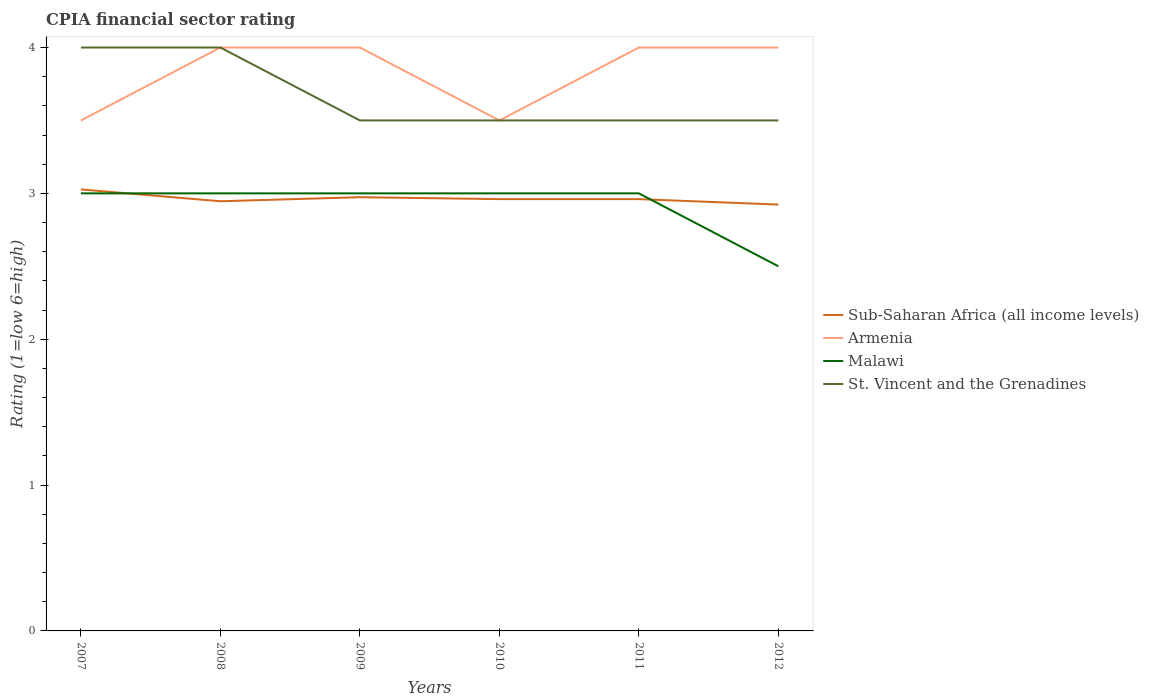How many different coloured lines are there?
Ensure brevity in your answer.  4. Is the number of lines equal to the number of legend labels?
Make the answer very short. Yes. In which year was the CPIA rating in Malawi maximum?
Your answer should be compact. 2012. What is the total CPIA rating in Sub-Saharan Africa (all income levels) in the graph?
Ensure brevity in your answer.  0.02. What is the difference between the highest and the lowest CPIA rating in Sub-Saharan Africa (all income levels)?
Provide a succinct answer. 2. Is the CPIA rating in Armenia strictly greater than the CPIA rating in Sub-Saharan Africa (all income levels) over the years?
Keep it short and to the point. No. How many lines are there?
Keep it short and to the point. 4. What is the difference between two consecutive major ticks on the Y-axis?
Offer a very short reply. 1. How many legend labels are there?
Offer a terse response. 4. How are the legend labels stacked?
Make the answer very short. Vertical. What is the title of the graph?
Keep it short and to the point. CPIA financial sector rating. Does "Norway" appear as one of the legend labels in the graph?
Your response must be concise. No. What is the label or title of the X-axis?
Provide a succinct answer. Years. What is the Rating (1=low 6=high) of Sub-Saharan Africa (all income levels) in 2007?
Provide a succinct answer. 3.03. What is the Rating (1=low 6=high) of Armenia in 2007?
Provide a short and direct response. 3.5. What is the Rating (1=low 6=high) of Sub-Saharan Africa (all income levels) in 2008?
Your response must be concise. 2.95. What is the Rating (1=low 6=high) of St. Vincent and the Grenadines in 2008?
Give a very brief answer. 4. What is the Rating (1=low 6=high) of Sub-Saharan Africa (all income levels) in 2009?
Provide a succinct answer. 2.97. What is the Rating (1=low 6=high) in Malawi in 2009?
Offer a terse response. 3. What is the Rating (1=low 6=high) of St. Vincent and the Grenadines in 2009?
Keep it short and to the point. 3.5. What is the Rating (1=low 6=high) of Sub-Saharan Africa (all income levels) in 2010?
Offer a very short reply. 2.96. What is the Rating (1=low 6=high) in Armenia in 2010?
Make the answer very short. 3.5. What is the Rating (1=low 6=high) in Sub-Saharan Africa (all income levels) in 2011?
Offer a very short reply. 2.96. What is the Rating (1=low 6=high) in Malawi in 2011?
Your response must be concise. 3. What is the Rating (1=low 6=high) in St. Vincent and the Grenadines in 2011?
Keep it short and to the point. 3.5. What is the Rating (1=low 6=high) in Sub-Saharan Africa (all income levels) in 2012?
Your answer should be compact. 2.92. What is the Rating (1=low 6=high) in Malawi in 2012?
Keep it short and to the point. 2.5. What is the Rating (1=low 6=high) in St. Vincent and the Grenadines in 2012?
Make the answer very short. 3.5. Across all years, what is the maximum Rating (1=low 6=high) in Sub-Saharan Africa (all income levels)?
Your answer should be very brief. 3.03. Across all years, what is the maximum Rating (1=low 6=high) of Armenia?
Provide a succinct answer. 4. Across all years, what is the maximum Rating (1=low 6=high) in Malawi?
Offer a terse response. 3. Across all years, what is the minimum Rating (1=low 6=high) in Sub-Saharan Africa (all income levels)?
Give a very brief answer. 2.92. Across all years, what is the minimum Rating (1=low 6=high) in Malawi?
Make the answer very short. 2.5. What is the total Rating (1=low 6=high) of Sub-Saharan Africa (all income levels) in the graph?
Your answer should be compact. 17.79. What is the total Rating (1=low 6=high) in Armenia in the graph?
Provide a succinct answer. 23. What is the total Rating (1=low 6=high) of Malawi in the graph?
Your response must be concise. 17.5. What is the total Rating (1=low 6=high) of St. Vincent and the Grenadines in the graph?
Offer a terse response. 22. What is the difference between the Rating (1=low 6=high) of Sub-Saharan Africa (all income levels) in 2007 and that in 2008?
Provide a succinct answer. 0.08. What is the difference between the Rating (1=low 6=high) of Armenia in 2007 and that in 2008?
Make the answer very short. -0.5. What is the difference between the Rating (1=low 6=high) in St. Vincent and the Grenadines in 2007 and that in 2008?
Offer a very short reply. 0. What is the difference between the Rating (1=low 6=high) in Sub-Saharan Africa (all income levels) in 2007 and that in 2009?
Offer a terse response. 0.05. What is the difference between the Rating (1=low 6=high) in Malawi in 2007 and that in 2009?
Give a very brief answer. 0. What is the difference between the Rating (1=low 6=high) of St. Vincent and the Grenadines in 2007 and that in 2009?
Ensure brevity in your answer.  0.5. What is the difference between the Rating (1=low 6=high) of Sub-Saharan Africa (all income levels) in 2007 and that in 2010?
Give a very brief answer. 0.07. What is the difference between the Rating (1=low 6=high) of Armenia in 2007 and that in 2010?
Your answer should be very brief. 0. What is the difference between the Rating (1=low 6=high) in Sub-Saharan Africa (all income levels) in 2007 and that in 2011?
Offer a very short reply. 0.07. What is the difference between the Rating (1=low 6=high) of Malawi in 2007 and that in 2011?
Give a very brief answer. 0. What is the difference between the Rating (1=low 6=high) of Sub-Saharan Africa (all income levels) in 2007 and that in 2012?
Provide a succinct answer. 0.1. What is the difference between the Rating (1=low 6=high) of Armenia in 2007 and that in 2012?
Your answer should be compact. -0.5. What is the difference between the Rating (1=low 6=high) of Malawi in 2007 and that in 2012?
Provide a short and direct response. 0.5. What is the difference between the Rating (1=low 6=high) in St. Vincent and the Grenadines in 2007 and that in 2012?
Your response must be concise. 0.5. What is the difference between the Rating (1=low 6=high) in Sub-Saharan Africa (all income levels) in 2008 and that in 2009?
Provide a succinct answer. -0.03. What is the difference between the Rating (1=low 6=high) of Armenia in 2008 and that in 2009?
Ensure brevity in your answer.  0. What is the difference between the Rating (1=low 6=high) in St. Vincent and the Grenadines in 2008 and that in 2009?
Ensure brevity in your answer.  0.5. What is the difference between the Rating (1=low 6=high) of Sub-Saharan Africa (all income levels) in 2008 and that in 2010?
Your response must be concise. -0.01. What is the difference between the Rating (1=low 6=high) in Armenia in 2008 and that in 2010?
Provide a short and direct response. 0.5. What is the difference between the Rating (1=low 6=high) in Malawi in 2008 and that in 2010?
Your response must be concise. 0. What is the difference between the Rating (1=low 6=high) of Sub-Saharan Africa (all income levels) in 2008 and that in 2011?
Make the answer very short. -0.01. What is the difference between the Rating (1=low 6=high) in St. Vincent and the Grenadines in 2008 and that in 2011?
Provide a succinct answer. 0.5. What is the difference between the Rating (1=low 6=high) of Sub-Saharan Africa (all income levels) in 2008 and that in 2012?
Provide a short and direct response. 0.02. What is the difference between the Rating (1=low 6=high) of Armenia in 2008 and that in 2012?
Keep it short and to the point. 0. What is the difference between the Rating (1=low 6=high) of Sub-Saharan Africa (all income levels) in 2009 and that in 2010?
Offer a very short reply. 0.01. What is the difference between the Rating (1=low 6=high) of St. Vincent and the Grenadines in 2009 and that in 2010?
Provide a succinct answer. 0. What is the difference between the Rating (1=low 6=high) of Sub-Saharan Africa (all income levels) in 2009 and that in 2011?
Provide a succinct answer. 0.01. What is the difference between the Rating (1=low 6=high) of Malawi in 2009 and that in 2011?
Provide a succinct answer. 0. What is the difference between the Rating (1=low 6=high) in St. Vincent and the Grenadines in 2009 and that in 2011?
Offer a very short reply. 0. What is the difference between the Rating (1=low 6=high) of Sub-Saharan Africa (all income levels) in 2009 and that in 2012?
Your answer should be compact. 0.05. What is the difference between the Rating (1=low 6=high) in Sub-Saharan Africa (all income levels) in 2010 and that in 2012?
Provide a short and direct response. 0.04. What is the difference between the Rating (1=low 6=high) of St. Vincent and the Grenadines in 2010 and that in 2012?
Ensure brevity in your answer.  0. What is the difference between the Rating (1=low 6=high) in Sub-Saharan Africa (all income levels) in 2011 and that in 2012?
Your answer should be very brief. 0.04. What is the difference between the Rating (1=low 6=high) in Malawi in 2011 and that in 2012?
Make the answer very short. 0.5. What is the difference between the Rating (1=low 6=high) in Sub-Saharan Africa (all income levels) in 2007 and the Rating (1=low 6=high) in Armenia in 2008?
Give a very brief answer. -0.97. What is the difference between the Rating (1=low 6=high) in Sub-Saharan Africa (all income levels) in 2007 and the Rating (1=low 6=high) in Malawi in 2008?
Make the answer very short. 0.03. What is the difference between the Rating (1=low 6=high) of Sub-Saharan Africa (all income levels) in 2007 and the Rating (1=low 6=high) of St. Vincent and the Grenadines in 2008?
Make the answer very short. -0.97. What is the difference between the Rating (1=low 6=high) in Sub-Saharan Africa (all income levels) in 2007 and the Rating (1=low 6=high) in Armenia in 2009?
Make the answer very short. -0.97. What is the difference between the Rating (1=low 6=high) in Sub-Saharan Africa (all income levels) in 2007 and the Rating (1=low 6=high) in Malawi in 2009?
Your answer should be very brief. 0.03. What is the difference between the Rating (1=low 6=high) of Sub-Saharan Africa (all income levels) in 2007 and the Rating (1=low 6=high) of St. Vincent and the Grenadines in 2009?
Offer a terse response. -0.47. What is the difference between the Rating (1=low 6=high) in Armenia in 2007 and the Rating (1=low 6=high) in Malawi in 2009?
Offer a terse response. 0.5. What is the difference between the Rating (1=low 6=high) in Armenia in 2007 and the Rating (1=low 6=high) in St. Vincent and the Grenadines in 2009?
Offer a terse response. 0. What is the difference between the Rating (1=low 6=high) in Sub-Saharan Africa (all income levels) in 2007 and the Rating (1=low 6=high) in Armenia in 2010?
Offer a very short reply. -0.47. What is the difference between the Rating (1=low 6=high) of Sub-Saharan Africa (all income levels) in 2007 and the Rating (1=low 6=high) of Malawi in 2010?
Your answer should be very brief. 0.03. What is the difference between the Rating (1=low 6=high) of Sub-Saharan Africa (all income levels) in 2007 and the Rating (1=low 6=high) of St. Vincent and the Grenadines in 2010?
Your answer should be compact. -0.47. What is the difference between the Rating (1=low 6=high) in Sub-Saharan Africa (all income levels) in 2007 and the Rating (1=low 6=high) in Armenia in 2011?
Make the answer very short. -0.97. What is the difference between the Rating (1=low 6=high) in Sub-Saharan Africa (all income levels) in 2007 and the Rating (1=low 6=high) in Malawi in 2011?
Keep it short and to the point. 0.03. What is the difference between the Rating (1=low 6=high) in Sub-Saharan Africa (all income levels) in 2007 and the Rating (1=low 6=high) in St. Vincent and the Grenadines in 2011?
Give a very brief answer. -0.47. What is the difference between the Rating (1=low 6=high) in Armenia in 2007 and the Rating (1=low 6=high) in St. Vincent and the Grenadines in 2011?
Provide a succinct answer. 0. What is the difference between the Rating (1=low 6=high) in Malawi in 2007 and the Rating (1=low 6=high) in St. Vincent and the Grenadines in 2011?
Your answer should be very brief. -0.5. What is the difference between the Rating (1=low 6=high) in Sub-Saharan Africa (all income levels) in 2007 and the Rating (1=low 6=high) in Armenia in 2012?
Keep it short and to the point. -0.97. What is the difference between the Rating (1=low 6=high) of Sub-Saharan Africa (all income levels) in 2007 and the Rating (1=low 6=high) of Malawi in 2012?
Provide a short and direct response. 0.53. What is the difference between the Rating (1=low 6=high) of Sub-Saharan Africa (all income levels) in 2007 and the Rating (1=low 6=high) of St. Vincent and the Grenadines in 2012?
Offer a terse response. -0.47. What is the difference between the Rating (1=low 6=high) in Armenia in 2007 and the Rating (1=low 6=high) in Malawi in 2012?
Offer a terse response. 1. What is the difference between the Rating (1=low 6=high) of Malawi in 2007 and the Rating (1=low 6=high) of St. Vincent and the Grenadines in 2012?
Provide a succinct answer. -0.5. What is the difference between the Rating (1=low 6=high) in Sub-Saharan Africa (all income levels) in 2008 and the Rating (1=low 6=high) in Armenia in 2009?
Offer a very short reply. -1.05. What is the difference between the Rating (1=low 6=high) in Sub-Saharan Africa (all income levels) in 2008 and the Rating (1=low 6=high) in Malawi in 2009?
Keep it short and to the point. -0.05. What is the difference between the Rating (1=low 6=high) in Sub-Saharan Africa (all income levels) in 2008 and the Rating (1=low 6=high) in St. Vincent and the Grenadines in 2009?
Provide a succinct answer. -0.55. What is the difference between the Rating (1=low 6=high) of Armenia in 2008 and the Rating (1=low 6=high) of St. Vincent and the Grenadines in 2009?
Offer a very short reply. 0.5. What is the difference between the Rating (1=low 6=high) of Malawi in 2008 and the Rating (1=low 6=high) of St. Vincent and the Grenadines in 2009?
Your answer should be compact. -0.5. What is the difference between the Rating (1=low 6=high) in Sub-Saharan Africa (all income levels) in 2008 and the Rating (1=low 6=high) in Armenia in 2010?
Your answer should be compact. -0.55. What is the difference between the Rating (1=low 6=high) in Sub-Saharan Africa (all income levels) in 2008 and the Rating (1=low 6=high) in Malawi in 2010?
Your answer should be very brief. -0.05. What is the difference between the Rating (1=low 6=high) of Sub-Saharan Africa (all income levels) in 2008 and the Rating (1=low 6=high) of St. Vincent and the Grenadines in 2010?
Offer a terse response. -0.55. What is the difference between the Rating (1=low 6=high) of Armenia in 2008 and the Rating (1=low 6=high) of St. Vincent and the Grenadines in 2010?
Make the answer very short. 0.5. What is the difference between the Rating (1=low 6=high) in Malawi in 2008 and the Rating (1=low 6=high) in St. Vincent and the Grenadines in 2010?
Your answer should be very brief. -0.5. What is the difference between the Rating (1=low 6=high) of Sub-Saharan Africa (all income levels) in 2008 and the Rating (1=low 6=high) of Armenia in 2011?
Ensure brevity in your answer.  -1.05. What is the difference between the Rating (1=low 6=high) of Sub-Saharan Africa (all income levels) in 2008 and the Rating (1=low 6=high) of Malawi in 2011?
Keep it short and to the point. -0.05. What is the difference between the Rating (1=low 6=high) in Sub-Saharan Africa (all income levels) in 2008 and the Rating (1=low 6=high) in St. Vincent and the Grenadines in 2011?
Provide a short and direct response. -0.55. What is the difference between the Rating (1=low 6=high) of Armenia in 2008 and the Rating (1=low 6=high) of Malawi in 2011?
Offer a very short reply. 1. What is the difference between the Rating (1=low 6=high) in Sub-Saharan Africa (all income levels) in 2008 and the Rating (1=low 6=high) in Armenia in 2012?
Give a very brief answer. -1.05. What is the difference between the Rating (1=low 6=high) of Sub-Saharan Africa (all income levels) in 2008 and the Rating (1=low 6=high) of Malawi in 2012?
Ensure brevity in your answer.  0.45. What is the difference between the Rating (1=low 6=high) in Sub-Saharan Africa (all income levels) in 2008 and the Rating (1=low 6=high) in St. Vincent and the Grenadines in 2012?
Your answer should be very brief. -0.55. What is the difference between the Rating (1=low 6=high) in Armenia in 2008 and the Rating (1=low 6=high) in Malawi in 2012?
Offer a very short reply. 1.5. What is the difference between the Rating (1=low 6=high) in Sub-Saharan Africa (all income levels) in 2009 and the Rating (1=low 6=high) in Armenia in 2010?
Provide a succinct answer. -0.53. What is the difference between the Rating (1=low 6=high) of Sub-Saharan Africa (all income levels) in 2009 and the Rating (1=low 6=high) of Malawi in 2010?
Provide a succinct answer. -0.03. What is the difference between the Rating (1=low 6=high) of Sub-Saharan Africa (all income levels) in 2009 and the Rating (1=low 6=high) of St. Vincent and the Grenadines in 2010?
Your answer should be very brief. -0.53. What is the difference between the Rating (1=low 6=high) in Armenia in 2009 and the Rating (1=low 6=high) in Malawi in 2010?
Provide a succinct answer. 1. What is the difference between the Rating (1=low 6=high) in Sub-Saharan Africa (all income levels) in 2009 and the Rating (1=low 6=high) in Armenia in 2011?
Your answer should be very brief. -1.03. What is the difference between the Rating (1=low 6=high) of Sub-Saharan Africa (all income levels) in 2009 and the Rating (1=low 6=high) of Malawi in 2011?
Give a very brief answer. -0.03. What is the difference between the Rating (1=low 6=high) of Sub-Saharan Africa (all income levels) in 2009 and the Rating (1=low 6=high) of St. Vincent and the Grenadines in 2011?
Keep it short and to the point. -0.53. What is the difference between the Rating (1=low 6=high) in Armenia in 2009 and the Rating (1=low 6=high) in St. Vincent and the Grenadines in 2011?
Your answer should be very brief. 0.5. What is the difference between the Rating (1=low 6=high) in Malawi in 2009 and the Rating (1=low 6=high) in St. Vincent and the Grenadines in 2011?
Your answer should be very brief. -0.5. What is the difference between the Rating (1=low 6=high) of Sub-Saharan Africa (all income levels) in 2009 and the Rating (1=low 6=high) of Armenia in 2012?
Give a very brief answer. -1.03. What is the difference between the Rating (1=low 6=high) of Sub-Saharan Africa (all income levels) in 2009 and the Rating (1=low 6=high) of Malawi in 2012?
Your answer should be very brief. 0.47. What is the difference between the Rating (1=low 6=high) of Sub-Saharan Africa (all income levels) in 2009 and the Rating (1=low 6=high) of St. Vincent and the Grenadines in 2012?
Your answer should be very brief. -0.53. What is the difference between the Rating (1=low 6=high) in Armenia in 2009 and the Rating (1=low 6=high) in Malawi in 2012?
Give a very brief answer. 1.5. What is the difference between the Rating (1=low 6=high) in Armenia in 2009 and the Rating (1=low 6=high) in St. Vincent and the Grenadines in 2012?
Your answer should be compact. 0.5. What is the difference between the Rating (1=low 6=high) in Malawi in 2009 and the Rating (1=low 6=high) in St. Vincent and the Grenadines in 2012?
Offer a very short reply. -0.5. What is the difference between the Rating (1=low 6=high) in Sub-Saharan Africa (all income levels) in 2010 and the Rating (1=low 6=high) in Armenia in 2011?
Ensure brevity in your answer.  -1.04. What is the difference between the Rating (1=low 6=high) in Sub-Saharan Africa (all income levels) in 2010 and the Rating (1=low 6=high) in Malawi in 2011?
Your response must be concise. -0.04. What is the difference between the Rating (1=low 6=high) in Sub-Saharan Africa (all income levels) in 2010 and the Rating (1=low 6=high) in St. Vincent and the Grenadines in 2011?
Provide a succinct answer. -0.54. What is the difference between the Rating (1=low 6=high) in Armenia in 2010 and the Rating (1=low 6=high) in Malawi in 2011?
Your answer should be very brief. 0.5. What is the difference between the Rating (1=low 6=high) of Malawi in 2010 and the Rating (1=low 6=high) of St. Vincent and the Grenadines in 2011?
Offer a very short reply. -0.5. What is the difference between the Rating (1=low 6=high) in Sub-Saharan Africa (all income levels) in 2010 and the Rating (1=low 6=high) in Armenia in 2012?
Give a very brief answer. -1.04. What is the difference between the Rating (1=low 6=high) of Sub-Saharan Africa (all income levels) in 2010 and the Rating (1=low 6=high) of Malawi in 2012?
Offer a terse response. 0.46. What is the difference between the Rating (1=low 6=high) of Sub-Saharan Africa (all income levels) in 2010 and the Rating (1=low 6=high) of St. Vincent and the Grenadines in 2012?
Make the answer very short. -0.54. What is the difference between the Rating (1=low 6=high) of Armenia in 2010 and the Rating (1=low 6=high) of St. Vincent and the Grenadines in 2012?
Your answer should be very brief. 0. What is the difference between the Rating (1=low 6=high) in Malawi in 2010 and the Rating (1=low 6=high) in St. Vincent and the Grenadines in 2012?
Provide a succinct answer. -0.5. What is the difference between the Rating (1=low 6=high) of Sub-Saharan Africa (all income levels) in 2011 and the Rating (1=low 6=high) of Armenia in 2012?
Ensure brevity in your answer.  -1.04. What is the difference between the Rating (1=low 6=high) in Sub-Saharan Africa (all income levels) in 2011 and the Rating (1=low 6=high) in Malawi in 2012?
Provide a short and direct response. 0.46. What is the difference between the Rating (1=low 6=high) in Sub-Saharan Africa (all income levels) in 2011 and the Rating (1=low 6=high) in St. Vincent and the Grenadines in 2012?
Provide a short and direct response. -0.54. What is the average Rating (1=low 6=high) in Sub-Saharan Africa (all income levels) per year?
Keep it short and to the point. 2.97. What is the average Rating (1=low 6=high) of Armenia per year?
Your answer should be compact. 3.83. What is the average Rating (1=low 6=high) of Malawi per year?
Keep it short and to the point. 2.92. What is the average Rating (1=low 6=high) of St. Vincent and the Grenadines per year?
Your response must be concise. 3.67. In the year 2007, what is the difference between the Rating (1=low 6=high) in Sub-Saharan Africa (all income levels) and Rating (1=low 6=high) in Armenia?
Offer a terse response. -0.47. In the year 2007, what is the difference between the Rating (1=low 6=high) in Sub-Saharan Africa (all income levels) and Rating (1=low 6=high) in Malawi?
Provide a succinct answer. 0.03. In the year 2007, what is the difference between the Rating (1=low 6=high) of Sub-Saharan Africa (all income levels) and Rating (1=low 6=high) of St. Vincent and the Grenadines?
Give a very brief answer. -0.97. In the year 2007, what is the difference between the Rating (1=low 6=high) in Armenia and Rating (1=low 6=high) in Malawi?
Your answer should be compact. 0.5. In the year 2007, what is the difference between the Rating (1=low 6=high) of Armenia and Rating (1=low 6=high) of St. Vincent and the Grenadines?
Provide a succinct answer. -0.5. In the year 2007, what is the difference between the Rating (1=low 6=high) in Malawi and Rating (1=low 6=high) in St. Vincent and the Grenadines?
Provide a succinct answer. -1. In the year 2008, what is the difference between the Rating (1=low 6=high) of Sub-Saharan Africa (all income levels) and Rating (1=low 6=high) of Armenia?
Your answer should be compact. -1.05. In the year 2008, what is the difference between the Rating (1=low 6=high) in Sub-Saharan Africa (all income levels) and Rating (1=low 6=high) in Malawi?
Offer a very short reply. -0.05. In the year 2008, what is the difference between the Rating (1=low 6=high) of Sub-Saharan Africa (all income levels) and Rating (1=low 6=high) of St. Vincent and the Grenadines?
Offer a terse response. -1.05. In the year 2008, what is the difference between the Rating (1=low 6=high) of Armenia and Rating (1=low 6=high) of Malawi?
Offer a terse response. 1. In the year 2008, what is the difference between the Rating (1=low 6=high) of Armenia and Rating (1=low 6=high) of St. Vincent and the Grenadines?
Offer a terse response. 0. In the year 2008, what is the difference between the Rating (1=low 6=high) of Malawi and Rating (1=low 6=high) of St. Vincent and the Grenadines?
Give a very brief answer. -1. In the year 2009, what is the difference between the Rating (1=low 6=high) in Sub-Saharan Africa (all income levels) and Rating (1=low 6=high) in Armenia?
Make the answer very short. -1.03. In the year 2009, what is the difference between the Rating (1=low 6=high) in Sub-Saharan Africa (all income levels) and Rating (1=low 6=high) in Malawi?
Make the answer very short. -0.03. In the year 2009, what is the difference between the Rating (1=low 6=high) of Sub-Saharan Africa (all income levels) and Rating (1=low 6=high) of St. Vincent and the Grenadines?
Keep it short and to the point. -0.53. In the year 2010, what is the difference between the Rating (1=low 6=high) of Sub-Saharan Africa (all income levels) and Rating (1=low 6=high) of Armenia?
Your answer should be compact. -0.54. In the year 2010, what is the difference between the Rating (1=low 6=high) in Sub-Saharan Africa (all income levels) and Rating (1=low 6=high) in Malawi?
Your answer should be compact. -0.04. In the year 2010, what is the difference between the Rating (1=low 6=high) of Sub-Saharan Africa (all income levels) and Rating (1=low 6=high) of St. Vincent and the Grenadines?
Keep it short and to the point. -0.54. In the year 2010, what is the difference between the Rating (1=low 6=high) in Armenia and Rating (1=low 6=high) in St. Vincent and the Grenadines?
Offer a terse response. 0. In the year 2010, what is the difference between the Rating (1=low 6=high) in Malawi and Rating (1=low 6=high) in St. Vincent and the Grenadines?
Provide a succinct answer. -0.5. In the year 2011, what is the difference between the Rating (1=low 6=high) in Sub-Saharan Africa (all income levels) and Rating (1=low 6=high) in Armenia?
Your answer should be compact. -1.04. In the year 2011, what is the difference between the Rating (1=low 6=high) in Sub-Saharan Africa (all income levels) and Rating (1=low 6=high) in Malawi?
Give a very brief answer. -0.04. In the year 2011, what is the difference between the Rating (1=low 6=high) of Sub-Saharan Africa (all income levels) and Rating (1=low 6=high) of St. Vincent and the Grenadines?
Your answer should be compact. -0.54. In the year 2011, what is the difference between the Rating (1=low 6=high) in Armenia and Rating (1=low 6=high) in Malawi?
Provide a short and direct response. 1. In the year 2011, what is the difference between the Rating (1=low 6=high) of Armenia and Rating (1=low 6=high) of St. Vincent and the Grenadines?
Your answer should be compact. 0.5. In the year 2012, what is the difference between the Rating (1=low 6=high) of Sub-Saharan Africa (all income levels) and Rating (1=low 6=high) of Armenia?
Your response must be concise. -1.08. In the year 2012, what is the difference between the Rating (1=low 6=high) of Sub-Saharan Africa (all income levels) and Rating (1=low 6=high) of Malawi?
Provide a succinct answer. 0.42. In the year 2012, what is the difference between the Rating (1=low 6=high) in Sub-Saharan Africa (all income levels) and Rating (1=low 6=high) in St. Vincent and the Grenadines?
Offer a terse response. -0.58. In the year 2012, what is the difference between the Rating (1=low 6=high) of Armenia and Rating (1=low 6=high) of Malawi?
Offer a very short reply. 1.5. In the year 2012, what is the difference between the Rating (1=low 6=high) in Armenia and Rating (1=low 6=high) in St. Vincent and the Grenadines?
Your answer should be compact. 0.5. What is the ratio of the Rating (1=low 6=high) of Sub-Saharan Africa (all income levels) in 2007 to that in 2008?
Provide a short and direct response. 1.03. What is the ratio of the Rating (1=low 6=high) in St. Vincent and the Grenadines in 2007 to that in 2008?
Provide a short and direct response. 1. What is the ratio of the Rating (1=low 6=high) of Sub-Saharan Africa (all income levels) in 2007 to that in 2009?
Your answer should be very brief. 1.02. What is the ratio of the Rating (1=low 6=high) in Malawi in 2007 to that in 2009?
Provide a short and direct response. 1. What is the ratio of the Rating (1=low 6=high) of St. Vincent and the Grenadines in 2007 to that in 2009?
Offer a terse response. 1.14. What is the ratio of the Rating (1=low 6=high) of Sub-Saharan Africa (all income levels) in 2007 to that in 2010?
Give a very brief answer. 1.02. What is the ratio of the Rating (1=low 6=high) in St. Vincent and the Grenadines in 2007 to that in 2010?
Make the answer very short. 1.14. What is the ratio of the Rating (1=low 6=high) of Sub-Saharan Africa (all income levels) in 2007 to that in 2011?
Your answer should be very brief. 1.02. What is the ratio of the Rating (1=low 6=high) of St. Vincent and the Grenadines in 2007 to that in 2011?
Provide a short and direct response. 1.14. What is the ratio of the Rating (1=low 6=high) in Sub-Saharan Africa (all income levels) in 2007 to that in 2012?
Ensure brevity in your answer.  1.04. What is the ratio of the Rating (1=low 6=high) in Armenia in 2007 to that in 2012?
Provide a succinct answer. 0.88. What is the ratio of the Rating (1=low 6=high) in Malawi in 2007 to that in 2012?
Your response must be concise. 1.2. What is the ratio of the Rating (1=low 6=high) in Sub-Saharan Africa (all income levels) in 2008 to that in 2009?
Keep it short and to the point. 0.99. What is the ratio of the Rating (1=low 6=high) of Malawi in 2008 to that in 2009?
Make the answer very short. 1. What is the ratio of the Rating (1=low 6=high) of St. Vincent and the Grenadines in 2008 to that in 2009?
Your response must be concise. 1.14. What is the ratio of the Rating (1=low 6=high) in Sub-Saharan Africa (all income levels) in 2008 to that in 2010?
Ensure brevity in your answer.  1. What is the ratio of the Rating (1=low 6=high) in Malawi in 2008 to that in 2010?
Your answer should be compact. 1. What is the ratio of the Rating (1=low 6=high) of St. Vincent and the Grenadines in 2008 to that in 2010?
Keep it short and to the point. 1.14. What is the ratio of the Rating (1=low 6=high) in Sub-Saharan Africa (all income levels) in 2008 to that in 2011?
Provide a succinct answer. 1. What is the ratio of the Rating (1=low 6=high) in Malawi in 2008 to that in 2011?
Provide a succinct answer. 1. What is the ratio of the Rating (1=low 6=high) in Sub-Saharan Africa (all income levels) in 2008 to that in 2012?
Provide a succinct answer. 1.01. What is the ratio of the Rating (1=low 6=high) in Malawi in 2008 to that in 2012?
Make the answer very short. 1.2. What is the ratio of the Rating (1=low 6=high) of Sub-Saharan Africa (all income levels) in 2009 to that in 2010?
Offer a terse response. 1. What is the ratio of the Rating (1=low 6=high) of Armenia in 2009 to that in 2010?
Give a very brief answer. 1.14. What is the ratio of the Rating (1=low 6=high) of Malawi in 2009 to that in 2010?
Provide a short and direct response. 1. What is the ratio of the Rating (1=low 6=high) of Armenia in 2009 to that in 2011?
Make the answer very short. 1. What is the ratio of the Rating (1=low 6=high) in Malawi in 2009 to that in 2011?
Offer a very short reply. 1. What is the ratio of the Rating (1=low 6=high) of St. Vincent and the Grenadines in 2009 to that in 2011?
Keep it short and to the point. 1. What is the ratio of the Rating (1=low 6=high) in Sub-Saharan Africa (all income levels) in 2009 to that in 2012?
Your response must be concise. 1.02. What is the ratio of the Rating (1=low 6=high) in Armenia in 2009 to that in 2012?
Provide a succinct answer. 1. What is the ratio of the Rating (1=low 6=high) in Malawi in 2009 to that in 2012?
Provide a succinct answer. 1.2. What is the ratio of the Rating (1=low 6=high) in Armenia in 2010 to that in 2011?
Provide a short and direct response. 0.88. What is the ratio of the Rating (1=low 6=high) of Malawi in 2010 to that in 2011?
Provide a short and direct response. 1. What is the ratio of the Rating (1=low 6=high) of St. Vincent and the Grenadines in 2010 to that in 2011?
Make the answer very short. 1. What is the ratio of the Rating (1=low 6=high) in Sub-Saharan Africa (all income levels) in 2010 to that in 2012?
Your response must be concise. 1.01. What is the ratio of the Rating (1=low 6=high) of Malawi in 2010 to that in 2012?
Your response must be concise. 1.2. What is the ratio of the Rating (1=low 6=high) in Sub-Saharan Africa (all income levels) in 2011 to that in 2012?
Give a very brief answer. 1.01. What is the ratio of the Rating (1=low 6=high) of Malawi in 2011 to that in 2012?
Keep it short and to the point. 1.2. What is the ratio of the Rating (1=low 6=high) of St. Vincent and the Grenadines in 2011 to that in 2012?
Ensure brevity in your answer.  1. What is the difference between the highest and the second highest Rating (1=low 6=high) in Sub-Saharan Africa (all income levels)?
Make the answer very short. 0.05. What is the difference between the highest and the second highest Rating (1=low 6=high) of Malawi?
Ensure brevity in your answer.  0. What is the difference between the highest and the second highest Rating (1=low 6=high) in St. Vincent and the Grenadines?
Your answer should be very brief. 0. What is the difference between the highest and the lowest Rating (1=low 6=high) in Sub-Saharan Africa (all income levels)?
Your answer should be very brief. 0.1. 